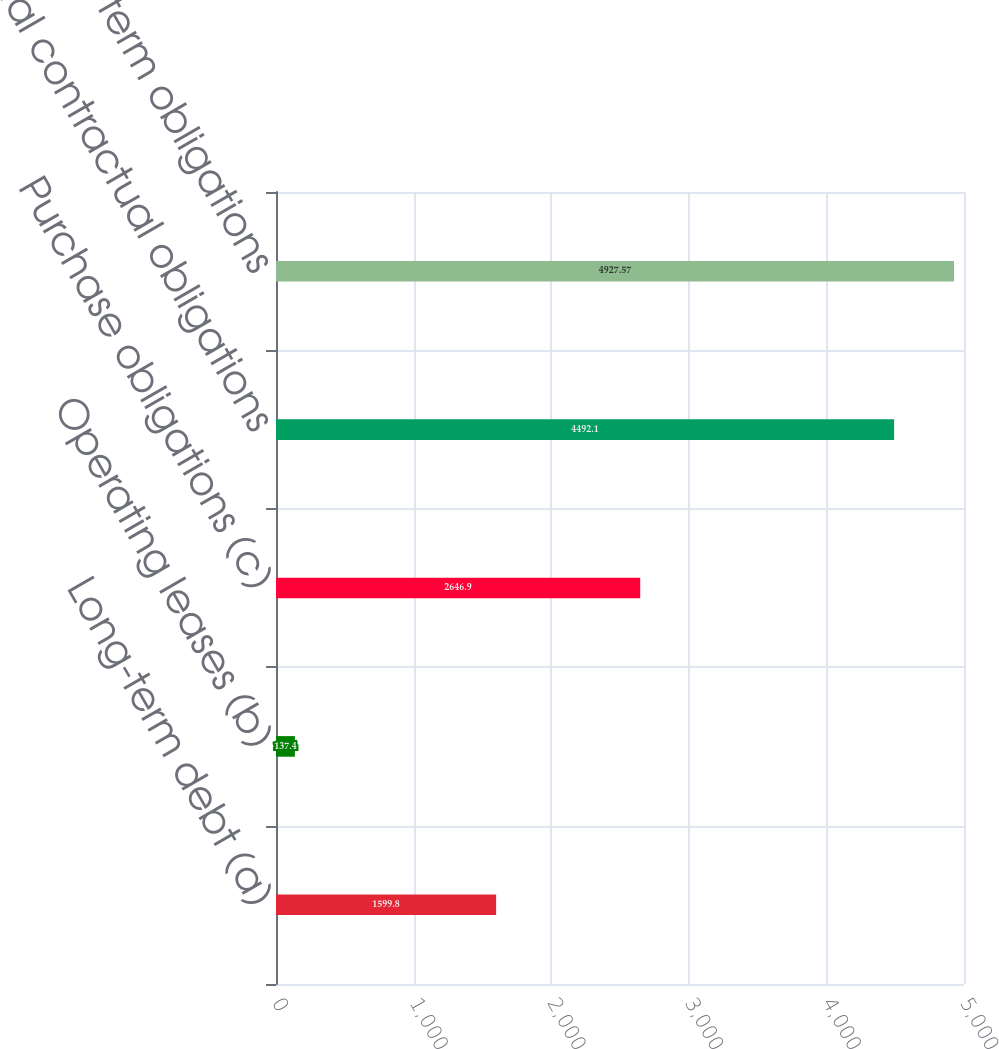<chart> <loc_0><loc_0><loc_500><loc_500><bar_chart><fcel>Long-term debt (a)<fcel>Operating leases (b)<fcel>Purchase obligations (c)<fcel>Total contractual obligations<fcel>Total long-term obligations<nl><fcel>1599.8<fcel>137.4<fcel>2646.9<fcel>4492.1<fcel>4927.57<nl></chart> 